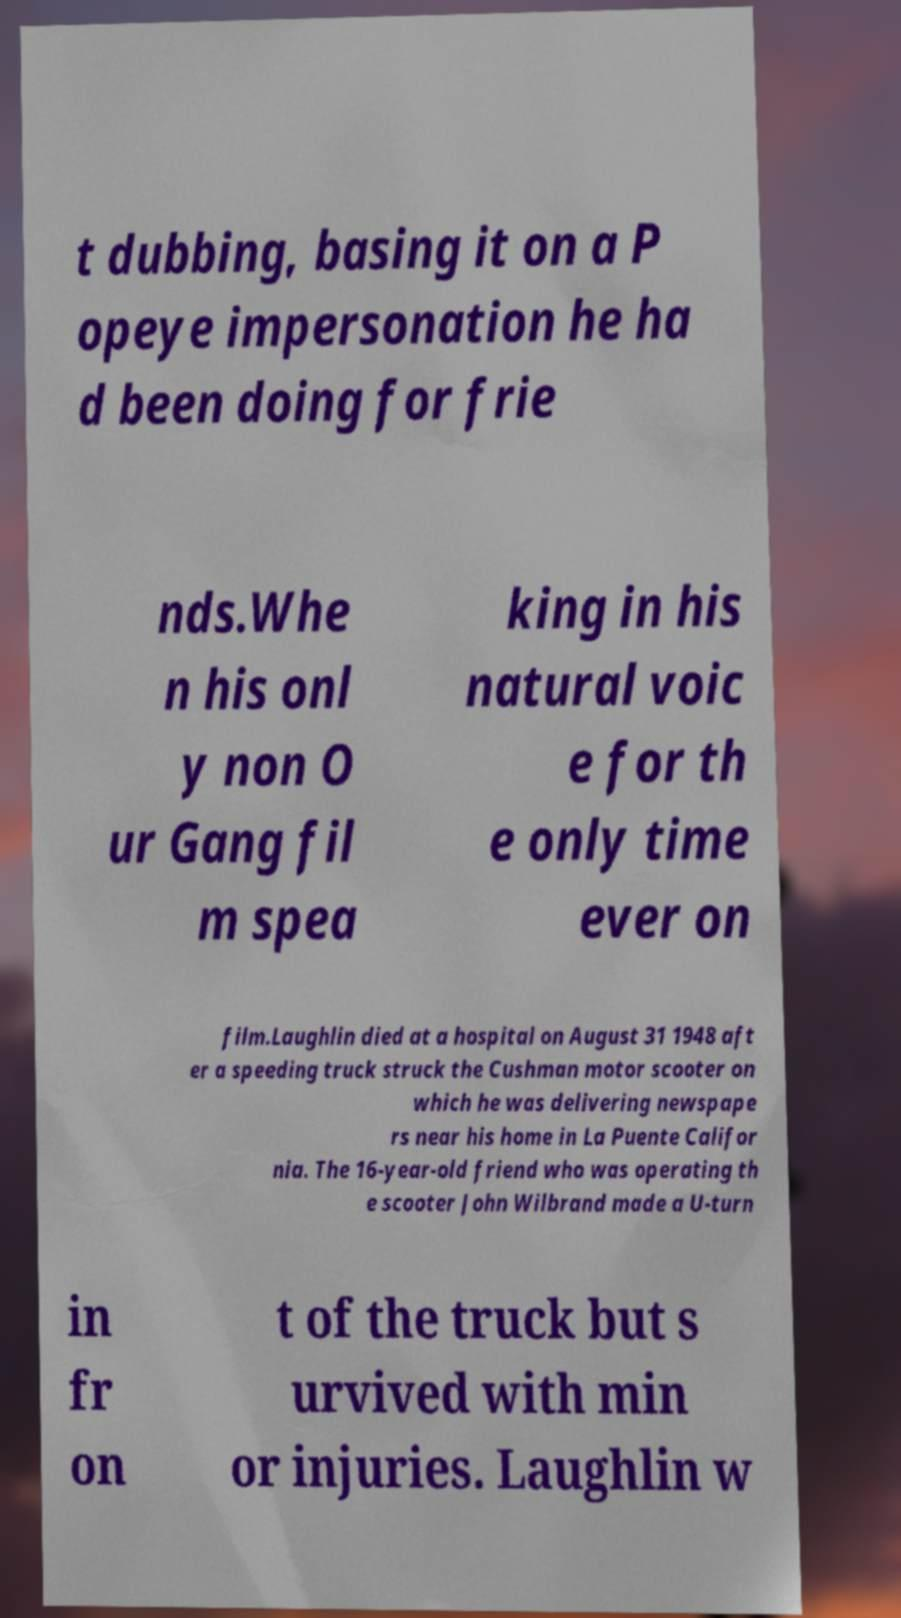For documentation purposes, I need the text within this image transcribed. Could you provide that? t dubbing, basing it on a P opeye impersonation he ha d been doing for frie nds.Whe n his onl y non O ur Gang fil m spea king in his natural voic e for th e only time ever on film.Laughlin died at a hospital on August 31 1948 aft er a speeding truck struck the Cushman motor scooter on which he was delivering newspape rs near his home in La Puente Califor nia. The 16-year-old friend who was operating th e scooter John Wilbrand made a U-turn in fr on t of the truck but s urvived with min or injuries. Laughlin w 